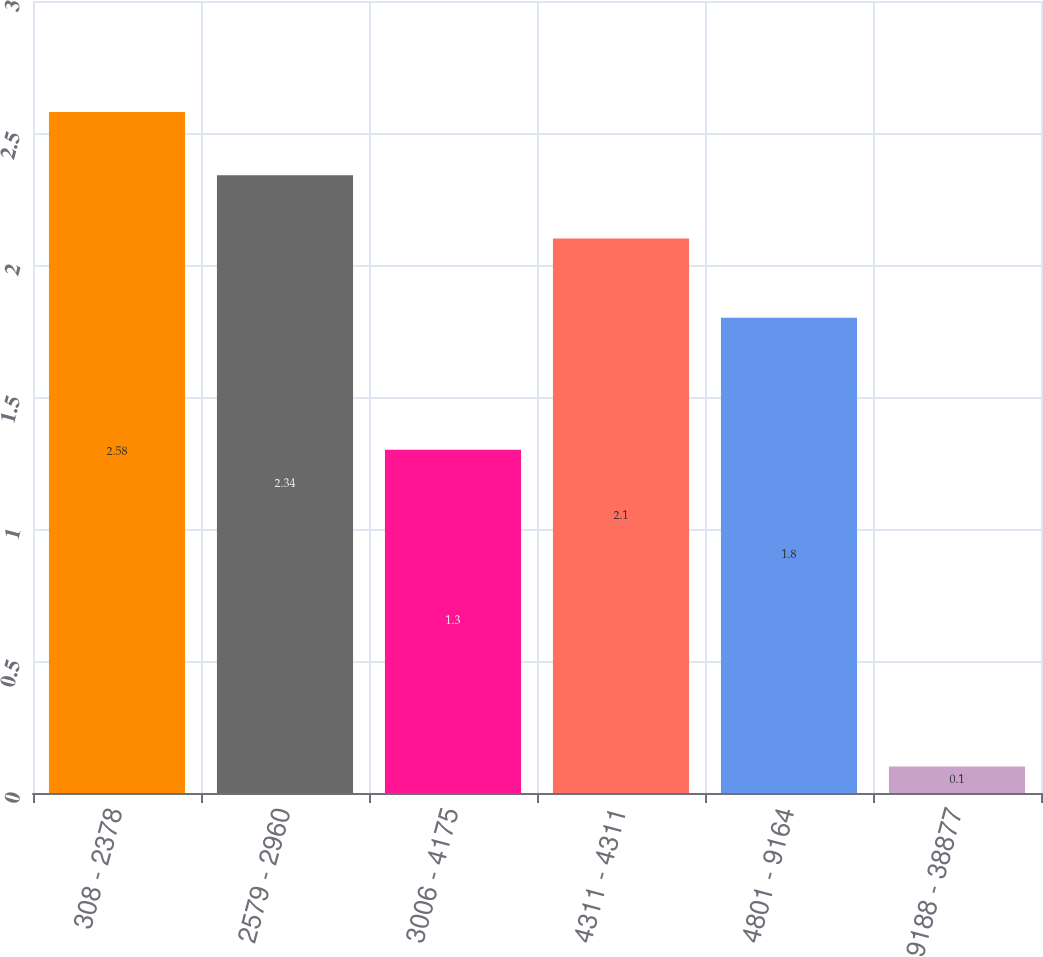Convert chart. <chart><loc_0><loc_0><loc_500><loc_500><bar_chart><fcel>308 - 2378<fcel>2579 - 2960<fcel>3006 - 4175<fcel>4311 - 4311<fcel>4801 - 9164<fcel>9188 - 38877<nl><fcel>2.58<fcel>2.34<fcel>1.3<fcel>2.1<fcel>1.8<fcel>0.1<nl></chart> 